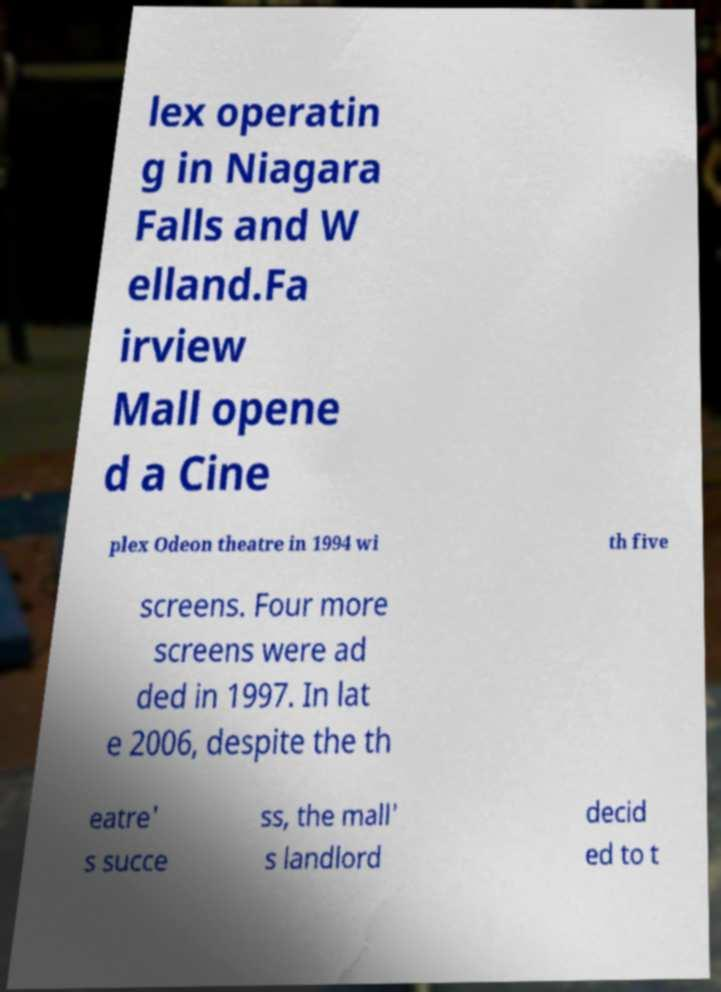Could you extract and type out the text from this image? lex operatin g in Niagara Falls and W elland.Fa irview Mall opene d a Cine plex Odeon theatre in 1994 wi th five screens. Four more screens were ad ded in 1997. In lat e 2006, despite the th eatre' s succe ss, the mall' s landlord decid ed to t 